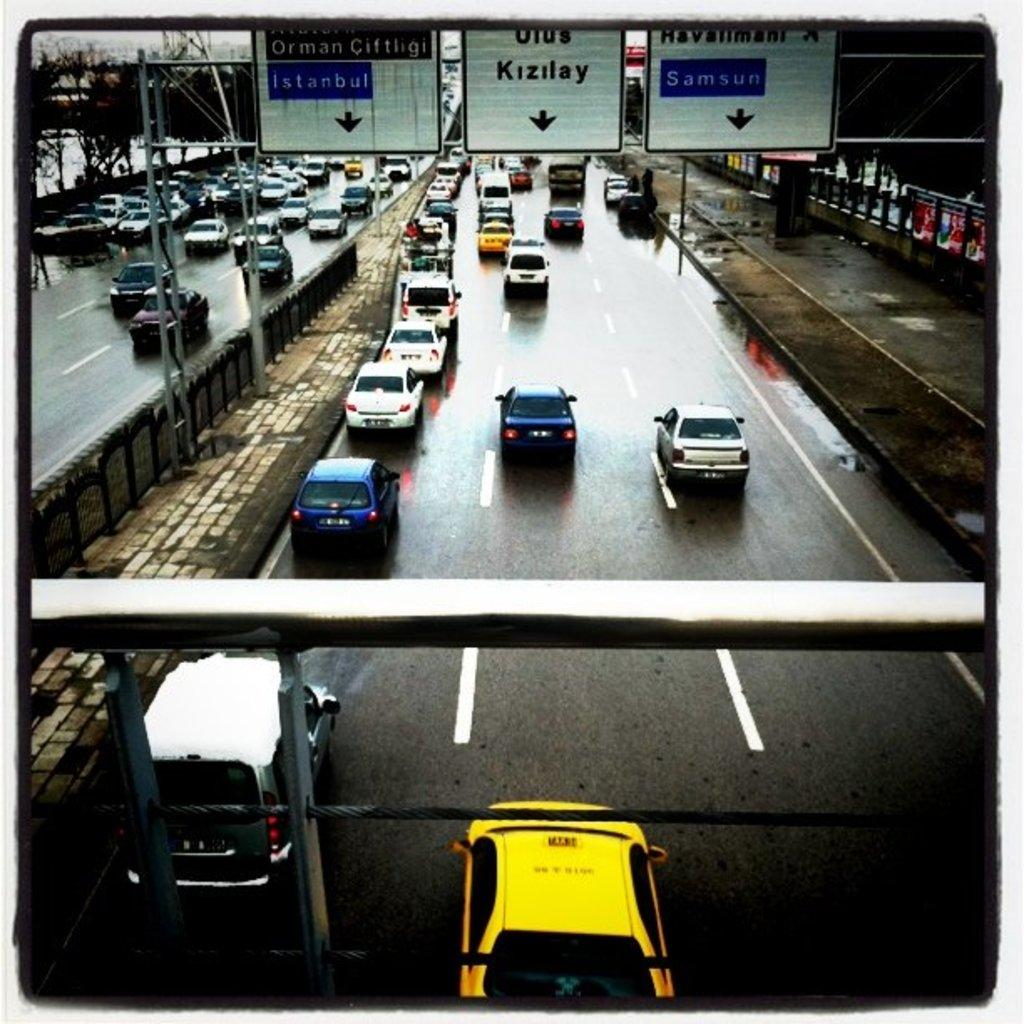<image>
Describe the image concisely. a road with Kisilay displayed above the road 